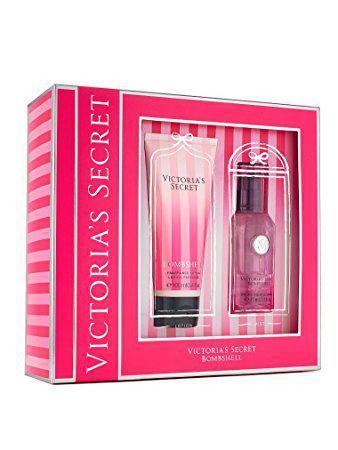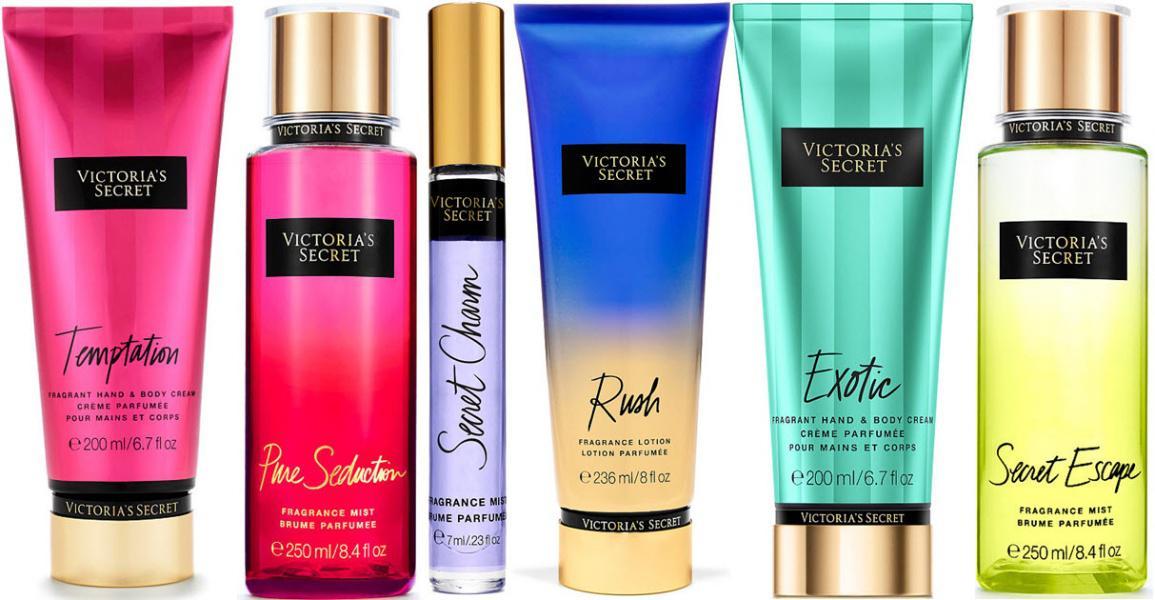The first image is the image on the left, the second image is the image on the right. Given the left and right images, does the statement "More beauty products are pictured in the left image than in the right image." hold true? Answer yes or no. No. The first image is the image on the left, the second image is the image on the right. For the images shown, is this caption "The bottles in the left image are arranged on a white cloth background." true? Answer yes or no. No. 